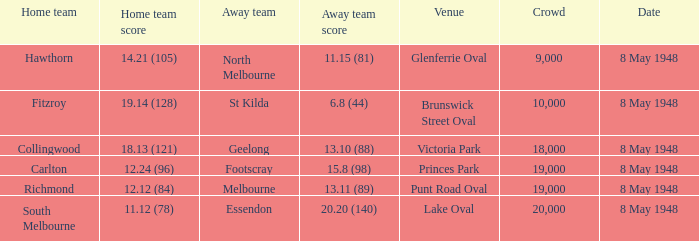Which visiting team was competing against the home team when they achieved a score of 14.21 (105)? North Melbourne. Write the full table. {'header': ['Home team', 'Home team score', 'Away team', 'Away team score', 'Venue', 'Crowd', 'Date'], 'rows': [['Hawthorn', '14.21 (105)', 'North Melbourne', '11.15 (81)', 'Glenferrie Oval', '9,000', '8 May 1948'], ['Fitzroy', '19.14 (128)', 'St Kilda', '6.8 (44)', 'Brunswick Street Oval', '10,000', '8 May 1948'], ['Collingwood', '18.13 (121)', 'Geelong', '13.10 (88)', 'Victoria Park', '18,000', '8 May 1948'], ['Carlton', '12.24 (96)', 'Footscray', '15.8 (98)', 'Princes Park', '19,000', '8 May 1948'], ['Richmond', '12.12 (84)', 'Melbourne', '13.11 (89)', 'Punt Road Oval', '19,000', '8 May 1948'], ['South Melbourne', '11.12 (78)', 'Essendon', '20.20 (140)', 'Lake Oval', '20,000', '8 May 1948']]} 